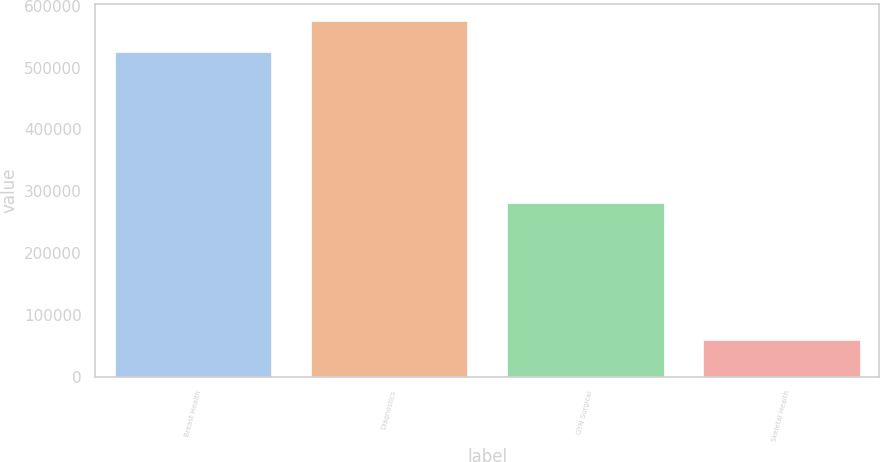<chart> <loc_0><loc_0><loc_500><loc_500><bar_chart><fcel>Breast Health<fcel>Diagnostics<fcel>GYN Surgical<fcel>Skeletal Health<nl><fcel>525622<fcel>574597<fcel>281364<fcel>59082<nl></chart> 